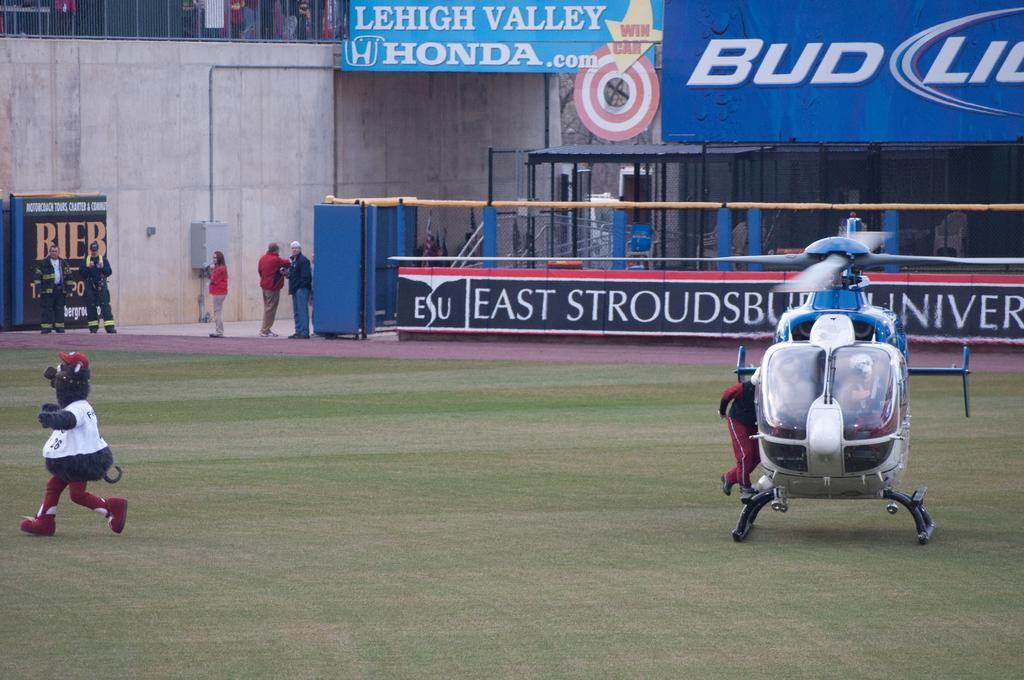What is the man in the image holding? The man in the image is holding costumes. How many people are visible in the image? There are persons in the image, including the man with costumes and others in the background. What is the helicopter's location in the image? The helicopter is on the grass in the image. What can be seen in the background of the image? In the background of the image, there are persons, advertisements, pillars, a shed, and a wall. What type of eggnog is being served at the recess in the image? There is no recess or eggnog present in the image. What color is the vest worn by the man in the image? The man in the image is not wearing a vest, so we cannot determine its color. 